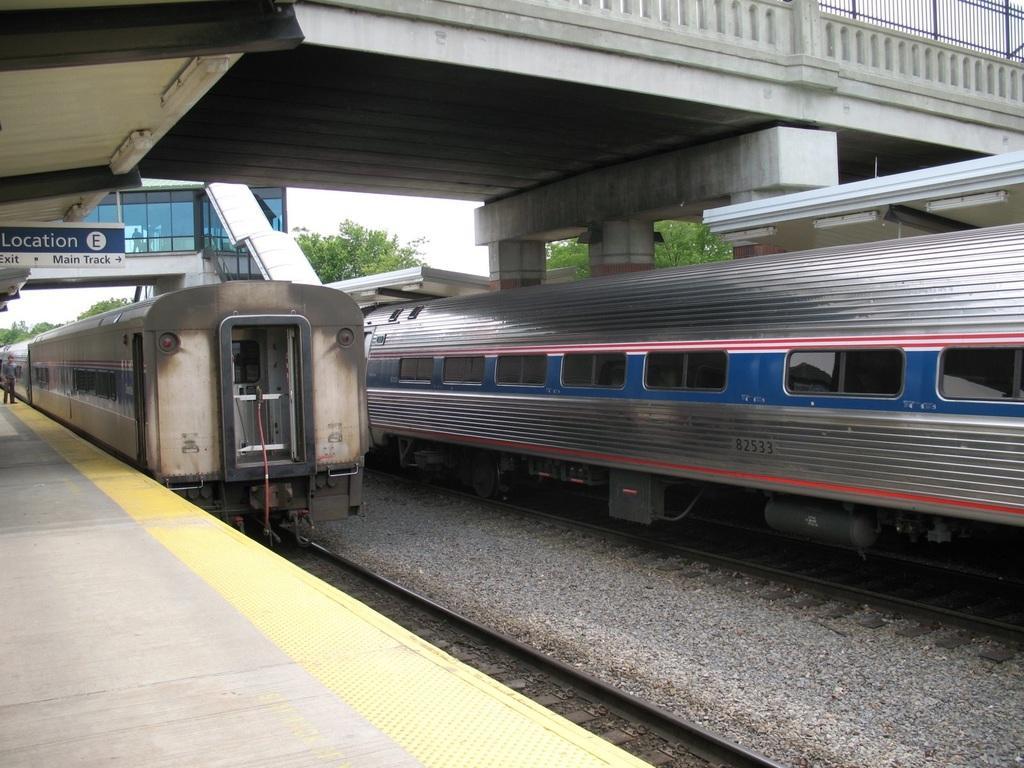Please provide a concise description of this image. This is a railway station. On the left side there is one person standing on the platform. In the middle of the image I can see two trains on the railway tracks. At the top of the image there is a bridge and I can see the railing. In the background there are some trees and also I can see the sky. 